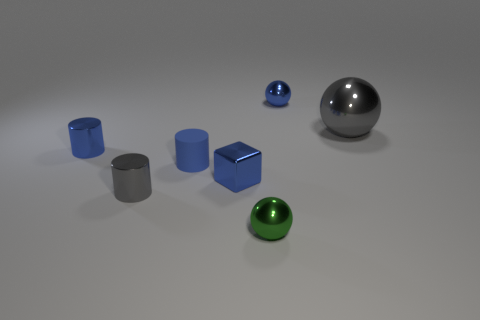The tiny matte cylinder is what color?
Offer a very short reply. Blue. Does the small ball behind the gray metallic sphere have the same color as the tiny cube?
Make the answer very short. Yes. The big object that is the same shape as the small green object is what color?
Provide a short and direct response. Gray. How many large objects are either blue cylinders or gray cylinders?
Offer a terse response. 0. There is a shiny ball that is behind the big shiny thing; what size is it?
Make the answer very short. Small. Is there a cube of the same color as the big ball?
Your answer should be compact. No. Is the color of the tiny rubber object the same as the big metallic sphere?
Provide a short and direct response. No. The small metal object that is the same color as the large thing is what shape?
Ensure brevity in your answer.  Cylinder. What number of large gray things are right of the blue metallic thing in front of the small rubber thing?
Give a very brief answer. 1. What number of green spheres are the same material as the large gray sphere?
Provide a succinct answer. 1. 